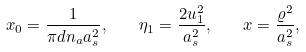<formula> <loc_0><loc_0><loc_500><loc_500>x _ { 0 } = \frac { 1 } { \pi d n _ { a } a _ { s } ^ { 2 } } , \quad \eta _ { 1 } = \frac { 2 u _ { 1 } ^ { 2 } } { a _ { s } ^ { 2 } } , \quad x = \frac { \varrho ^ { 2 } } { a _ { s } ^ { 2 } } ,</formula> 